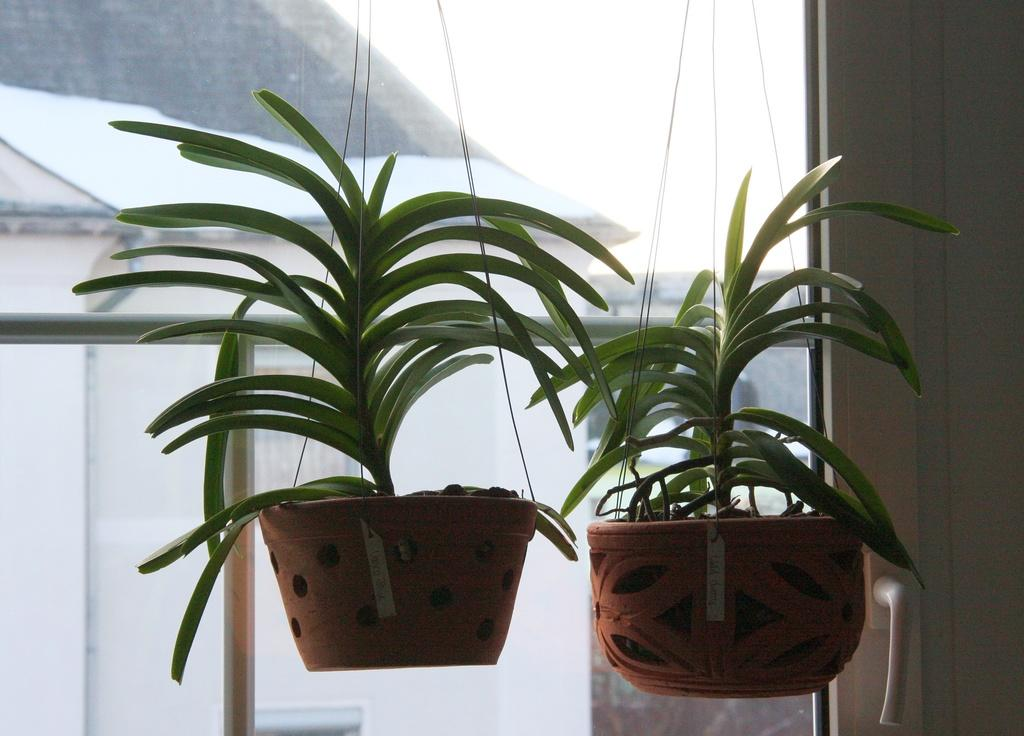What type of objects are in the image that are associated with plants? There are plants with pots in the image. Where is the door handle located in the image? The door handle is on the right side of the image. What material is visible in the image that is typically transparent? Glass is visible in the image. What can be seen through the glass in the image? Rods and additional unspecified objects are visible through the glass. What type of pear is being used to paste the nut onto the wall in the image? There is no pear, paste, or nut present in the image. 